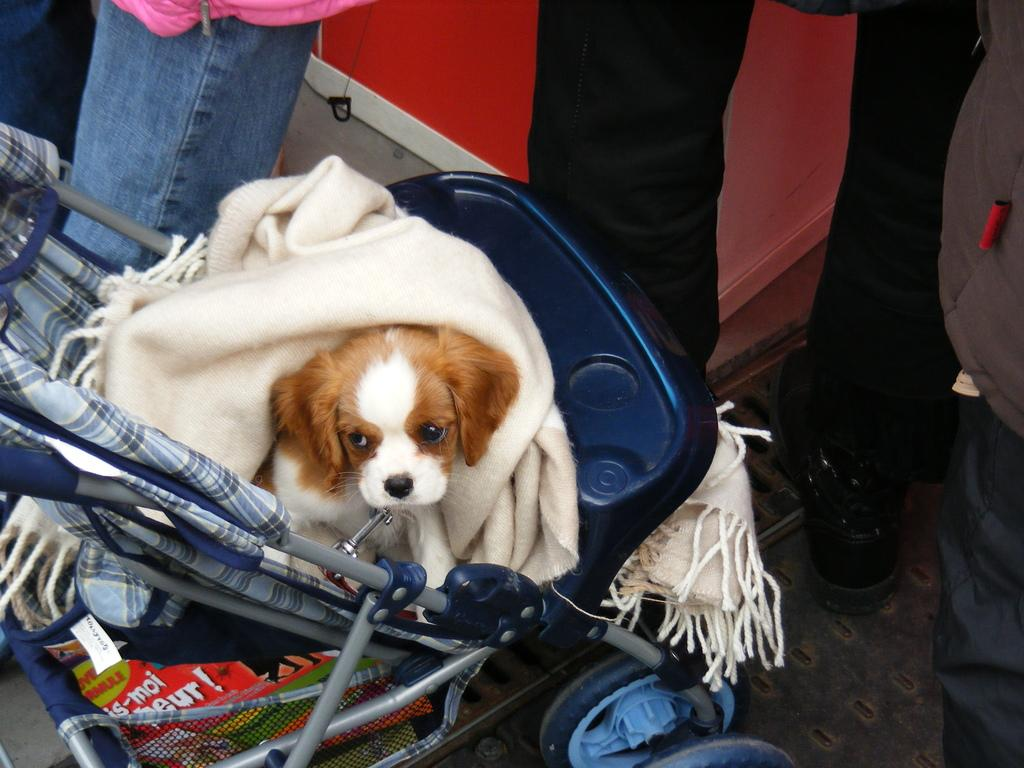What animal is in the image? There is a dog in the image. What is the dog sitting on? The dog is sitting on a stroller. What is the dog wearing? The dog is wearing a cloth. What else can be found in the stroller? There are other things in the stroller. Are there any people in the image? Yes, there are people present in the image. What type of yak can be seen grazing in the background of the image? There is no yak present in the image; it features a dog sitting on a stroller. How many quivers are visible on the dog in the image? There are no quivers present in the image; the dog is wearing a cloth. 